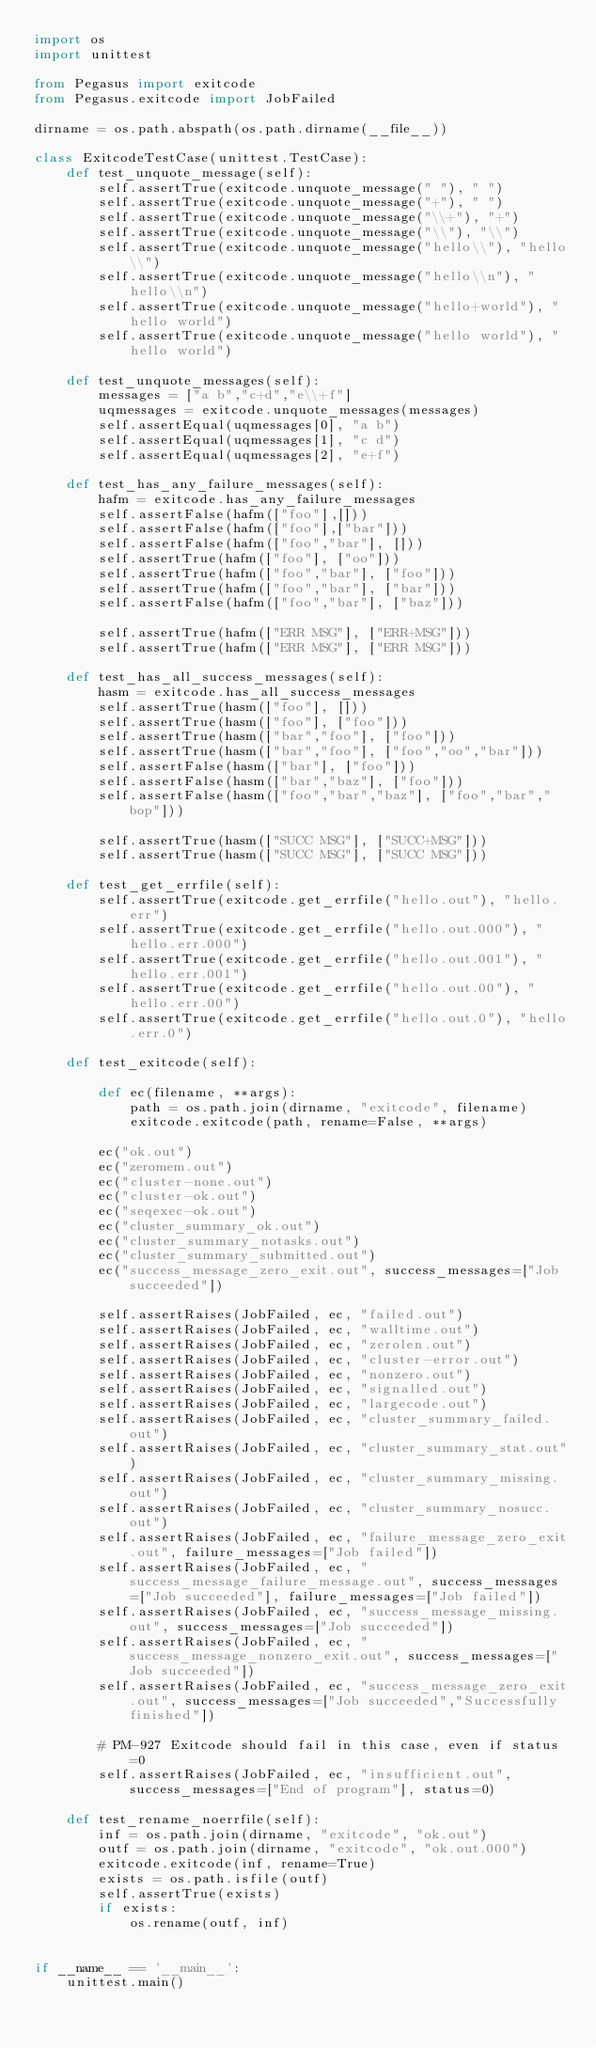<code> <loc_0><loc_0><loc_500><loc_500><_Python_>import os
import unittest

from Pegasus import exitcode
from Pegasus.exitcode import JobFailed

dirname = os.path.abspath(os.path.dirname(__file__))

class ExitcodeTestCase(unittest.TestCase):
    def test_unquote_message(self):
        self.assertTrue(exitcode.unquote_message(" "), " ")
        self.assertTrue(exitcode.unquote_message("+"), " ")
        self.assertTrue(exitcode.unquote_message("\\+"), "+")
        self.assertTrue(exitcode.unquote_message("\\"), "\\")
        self.assertTrue(exitcode.unquote_message("hello\\"), "hello\\")
        self.assertTrue(exitcode.unquote_message("hello\\n"), "hello\\n")
        self.assertTrue(exitcode.unquote_message("hello+world"), "hello world")
        self.assertTrue(exitcode.unquote_message("hello world"), "hello world")

    def test_unquote_messages(self):
        messages = ["a b","c+d","e\\+f"]
        uqmessages = exitcode.unquote_messages(messages)
        self.assertEqual(uqmessages[0], "a b")
        self.assertEqual(uqmessages[1], "c d")
        self.assertEqual(uqmessages[2], "e+f")

    def test_has_any_failure_messages(self):
        hafm = exitcode.has_any_failure_messages
        self.assertFalse(hafm(["foo"],[]))
        self.assertFalse(hafm(["foo"],["bar"]))
        self.assertFalse(hafm(["foo","bar"], []))
        self.assertTrue(hafm(["foo"], ["oo"]))
        self.assertTrue(hafm(["foo","bar"], ["foo"]))
        self.assertTrue(hafm(["foo","bar"], ["bar"]))
        self.assertFalse(hafm(["foo","bar"], ["baz"]))

        self.assertTrue(hafm(["ERR MSG"], ["ERR+MSG"]))
        self.assertTrue(hafm(["ERR MSG"], ["ERR MSG"]))

    def test_has_all_success_messages(self):
        hasm = exitcode.has_all_success_messages
        self.assertTrue(hasm(["foo"], []))
        self.assertTrue(hasm(["foo"], ["foo"]))
        self.assertTrue(hasm(["bar","foo"], ["foo"]))
        self.assertTrue(hasm(["bar","foo"], ["foo","oo","bar"]))
        self.assertFalse(hasm(["bar"], ["foo"]))
        self.assertFalse(hasm(["bar","baz"], ["foo"]))
        self.assertFalse(hasm(["foo","bar","baz"], ["foo","bar","bop"]))

        self.assertTrue(hasm(["SUCC MSG"], ["SUCC+MSG"]))
        self.assertTrue(hasm(["SUCC MSG"], ["SUCC MSG"]))

    def test_get_errfile(self):
        self.assertTrue(exitcode.get_errfile("hello.out"), "hello.err")
        self.assertTrue(exitcode.get_errfile("hello.out.000"), "hello.err.000")
        self.assertTrue(exitcode.get_errfile("hello.out.001"), "hello.err.001")
        self.assertTrue(exitcode.get_errfile("hello.out.00"), "hello.err.00")
        self.assertTrue(exitcode.get_errfile("hello.out.0"), "hello.err.0")

    def test_exitcode(self):

        def ec(filename, **args):
            path = os.path.join(dirname, "exitcode", filename)
            exitcode.exitcode(path, rename=False, **args)

        ec("ok.out")
        ec("zeromem.out")
        ec("cluster-none.out")
        ec("cluster-ok.out")
        ec("seqexec-ok.out")
        ec("cluster_summary_ok.out")
        ec("cluster_summary_notasks.out")
        ec("cluster_summary_submitted.out")
        ec("success_message_zero_exit.out", success_messages=["Job succeeded"])

        self.assertRaises(JobFailed, ec, "failed.out")
        self.assertRaises(JobFailed, ec, "walltime.out")
        self.assertRaises(JobFailed, ec, "zerolen.out")
        self.assertRaises(JobFailed, ec, "cluster-error.out")
        self.assertRaises(JobFailed, ec, "nonzero.out")
        self.assertRaises(JobFailed, ec, "signalled.out")
        self.assertRaises(JobFailed, ec, "largecode.out")
        self.assertRaises(JobFailed, ec, "cluster_summary_failed.out")
        self.assertRaises(JobFailed, ec, "cluster_summary_stat.out")
        self.assertRaises(JobFailed, ec, "cluster_summary_missing.out")
        self.assertRaises(JobFailed, ec, "cluster_summary_nosucc.out")
        self.assertRaises(JobFailed, ec, "failure_message_zero_exit.out", failure_messages=["Job failed"])
        self.assertRaises(JobFailed, ec, "success_message_failure_message.out", success_messages=["Job succeeded"], failure_messages=["Job failed"])
        self.assertRaises(JobFailed, ec, "success_message_missing.out", success_messages=["Job succeeded"])
        self.assertRaises(JobFailed, ec, "success_message_nonzero_exit.out", success_messages=["Job succeeded"])
        self.assertRaises(JobFailed, ec, "success_message_zero_exit.out", success_messages=["Job succeeded","Successfully finished"])

        # PM-927 Exitcode should fail in this case, even if status=0
        self.assertRaises(JobFailed, ec, "insufficient.out", success_messages=["End of program"], status=0)

    def test_rename_noerrfile(self):
        inf = os.path.join(dirname, "exitcode", "ok.out")
        outf = os.path.join(dirname, "exitcode", "ok.out.000")
        exitcode.exitcode(inf, rename=True)
        exists = os.path.isfile(outf)
        self.assertTrue(exists)
        if exists:
            os.rename(outf, inf)


if __name__ == '__main__':
    unittest.main()

</code> 